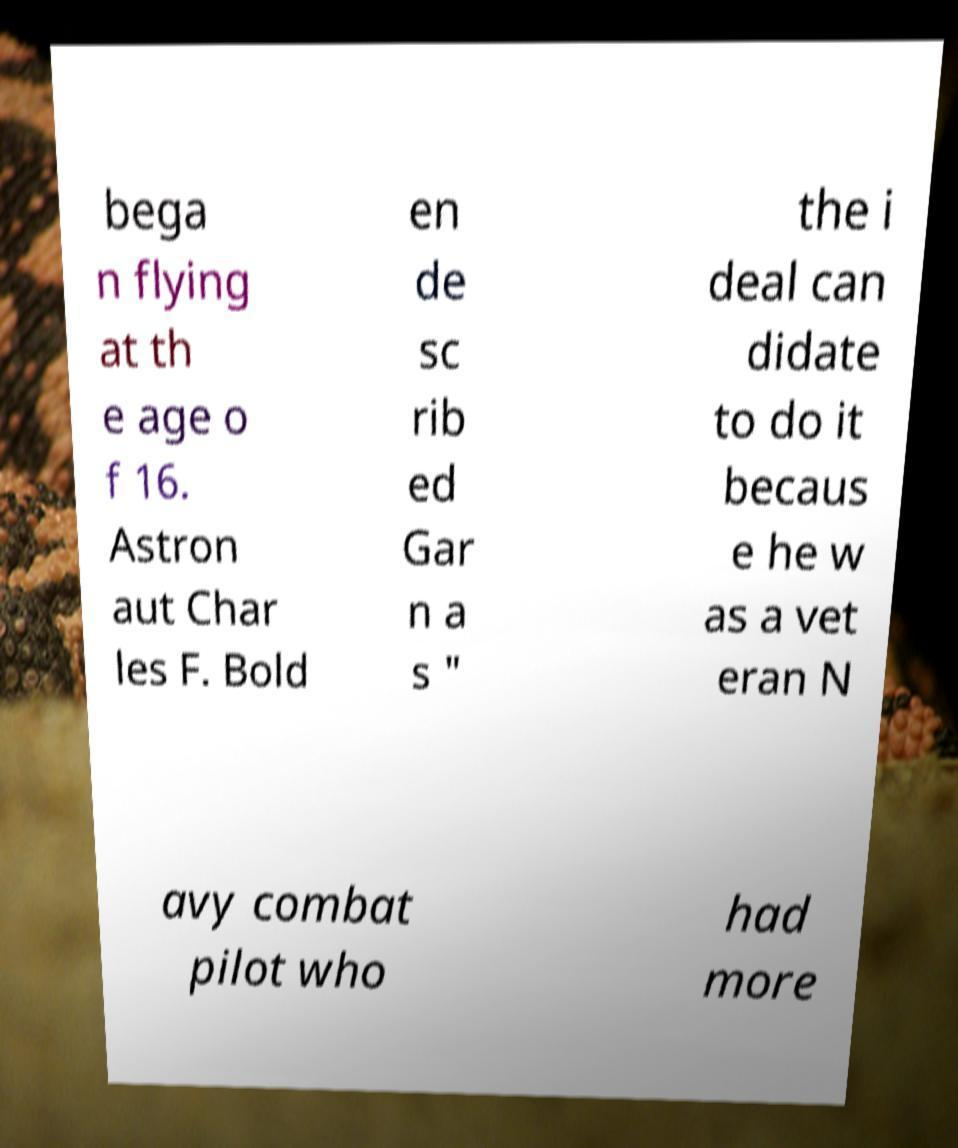Can you read and provide the text displayed in the image?This photo seems to have some interesting text. Can you extract and type it out for me? bega n flying at th e age o f 16. Astron aut Char les F. Bold en de sc rib ed Gar n a s " the i deal can didate to do it becaus e he w as a vet eran N avy combat pilot who had more 